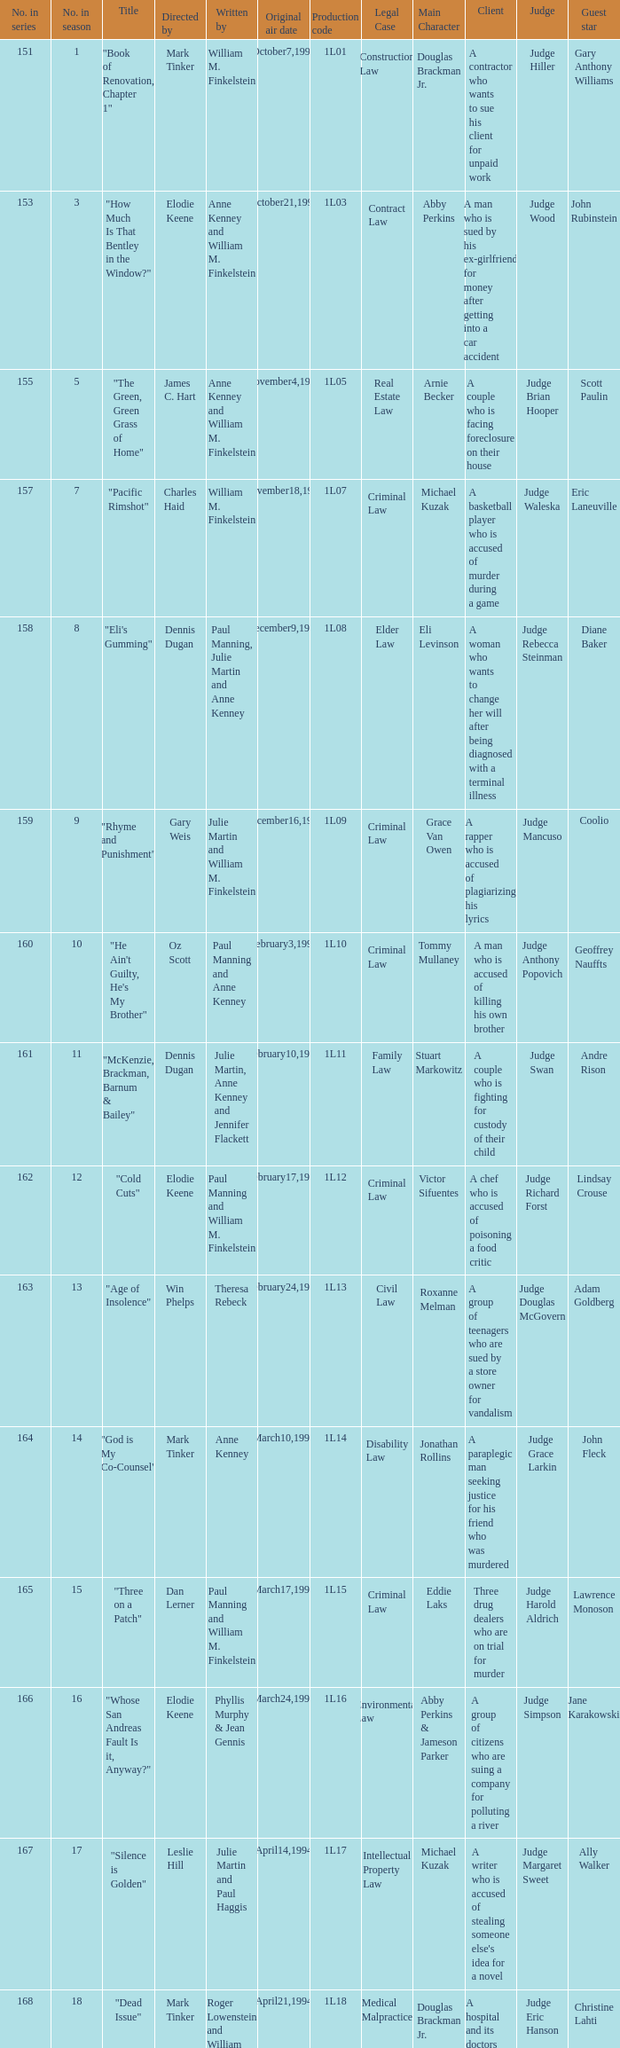Name the original air date for production code 1l16 March24,1994. 